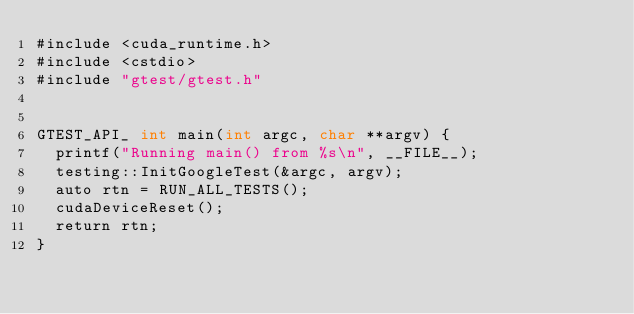Convert code to text. <code><loc_0><loc_0><loc_500><loc_500><_Cuda_>#include <cuda_runtime.h>
#include <cstdio>
#include "gtest/gtest.h"


GTEST_API_ int main(int argc, char **argv) {
  printf("Running main() from %s\n", __FILE__);
  testing::InitGoogleTest(&argc, argv);
  auto rtn = RUN_ALL_TESTS();
  cudaDeviceReset();
  return rtn;
}
</code> 